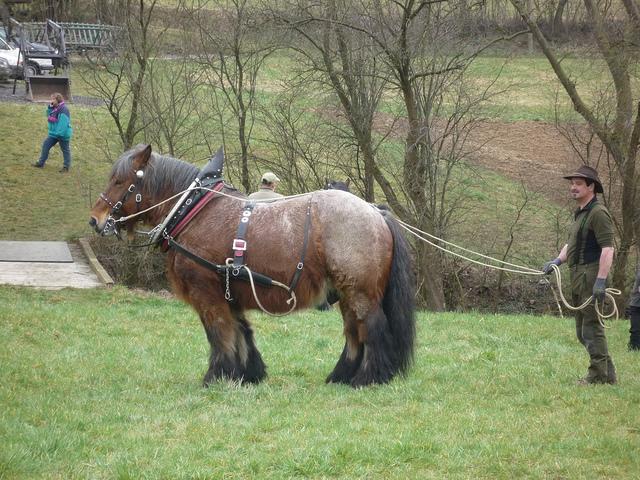How many ponies is this man standing behind?
Short answer required. 1. Is the man wearing a hat?
Be succinct. Yes. What kind of horses are these?
Keep it brief. Clydesdale. 